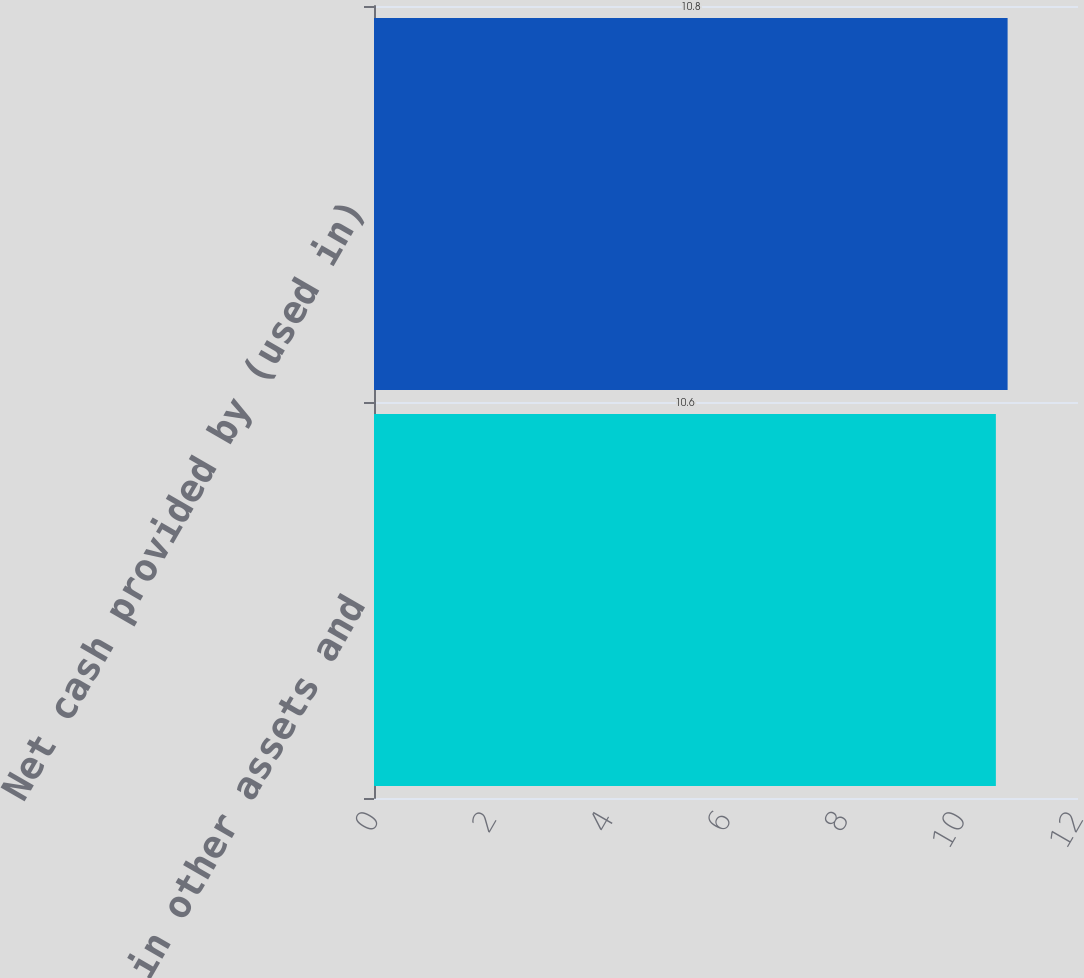<chart> <loc_0><loc_0><loc_500><loc_500><bar_chart><fcel>Change in other assets and<fcel>Net cash provided by (used in)<nl><fcel>10.6<fcel>10.8<nl></chart> 